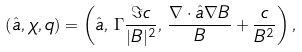<formula> <loc_0><loc_0><loc_500><loc_500>\left ( \hat { a } , \chi , q \right ) = \left ( \hat { a } , \, \Gamma \frac { \Im c } { | B | ^ { 2 } } , \, \frac { \nabla \cdot \hat { a } \nabla B } { B } + \frac { c } { B ^ { 2 } } \right ) ,</formula> 